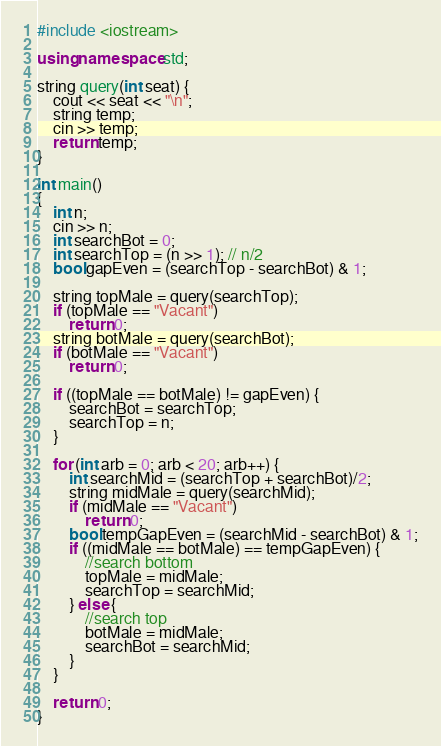Convert code to text. <code><loc_0><loc_0><loc_500><loc_500><_C++_>#include <iostream>

using namespace std;

string query(int seat) {
    cout << seat << "\n";
    string temp;
    cin >> temp;
    return temp;
}

int main()
{
    int n;
    cin >> n;
    int searchBot = 0;
    int searchTop = (n >> 1); // n/2
    bool gapEven = (searchTop - searchBot) & 1;
    
    string topMale = query(searchTop);
    if (topMale == "Vacant")
        return 0;
    string botMale = query(searchBot);
    if (botMale == "Vacant")
        return 0;
    
    if ((topMale == botMale) != gapEven) {
        searchBot = searchTop;
        searchTop = n;
    }
    
    for (int arb = 0; arb < 20; arb++) {
        int searchMid = (searchTop + searchBot)/2;
        string midMale = query(searchMid);
        if (midMale == "Vacant")
            return 0;
        bool tempGapEven = (searchMid - searchBot) & 1;
        if ((midMale == botMale) == tempGapEven) {
            //search bottom
            topMale = midMale;
            searchTop = searchMid;
        } else {
            //search top
            botMale = midMale;
            searchBot = searchMid;
        }
    }
    
    return 0;
}</code> 